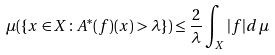Convert formula to latex. <formula><loc_0><loc_0><loc_500><loc_500>\mu ( \{ x \in X \colon A ^ { * } ( f ) ( x ) > \lambda \} ) \leq \frac { 2 } { \lambda } \int _ { X } | f | d \, \mu</formula> 